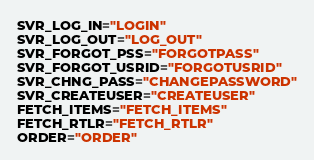<code> <loc_0><loc_0><loc_500><loc_500><_Python_>SVR_LOG_IN="LOGIN"
SVR_LOG_OUT="LOG_OUT"
SVR_FORGOT_PSS="FORGOTPASS"
SVR_FORGOT_USRID="FORGOTUSRID"
SVR_CHNG_PASS="CHANGEPASSWORD"
SVR_CREATEUSER="CREATEUSER"
FETCH_ITEMS="FETCH_ITEMS"
FETCH_RTLR="FETCH_RTLR"
ORDER="ORDER"
</code> 